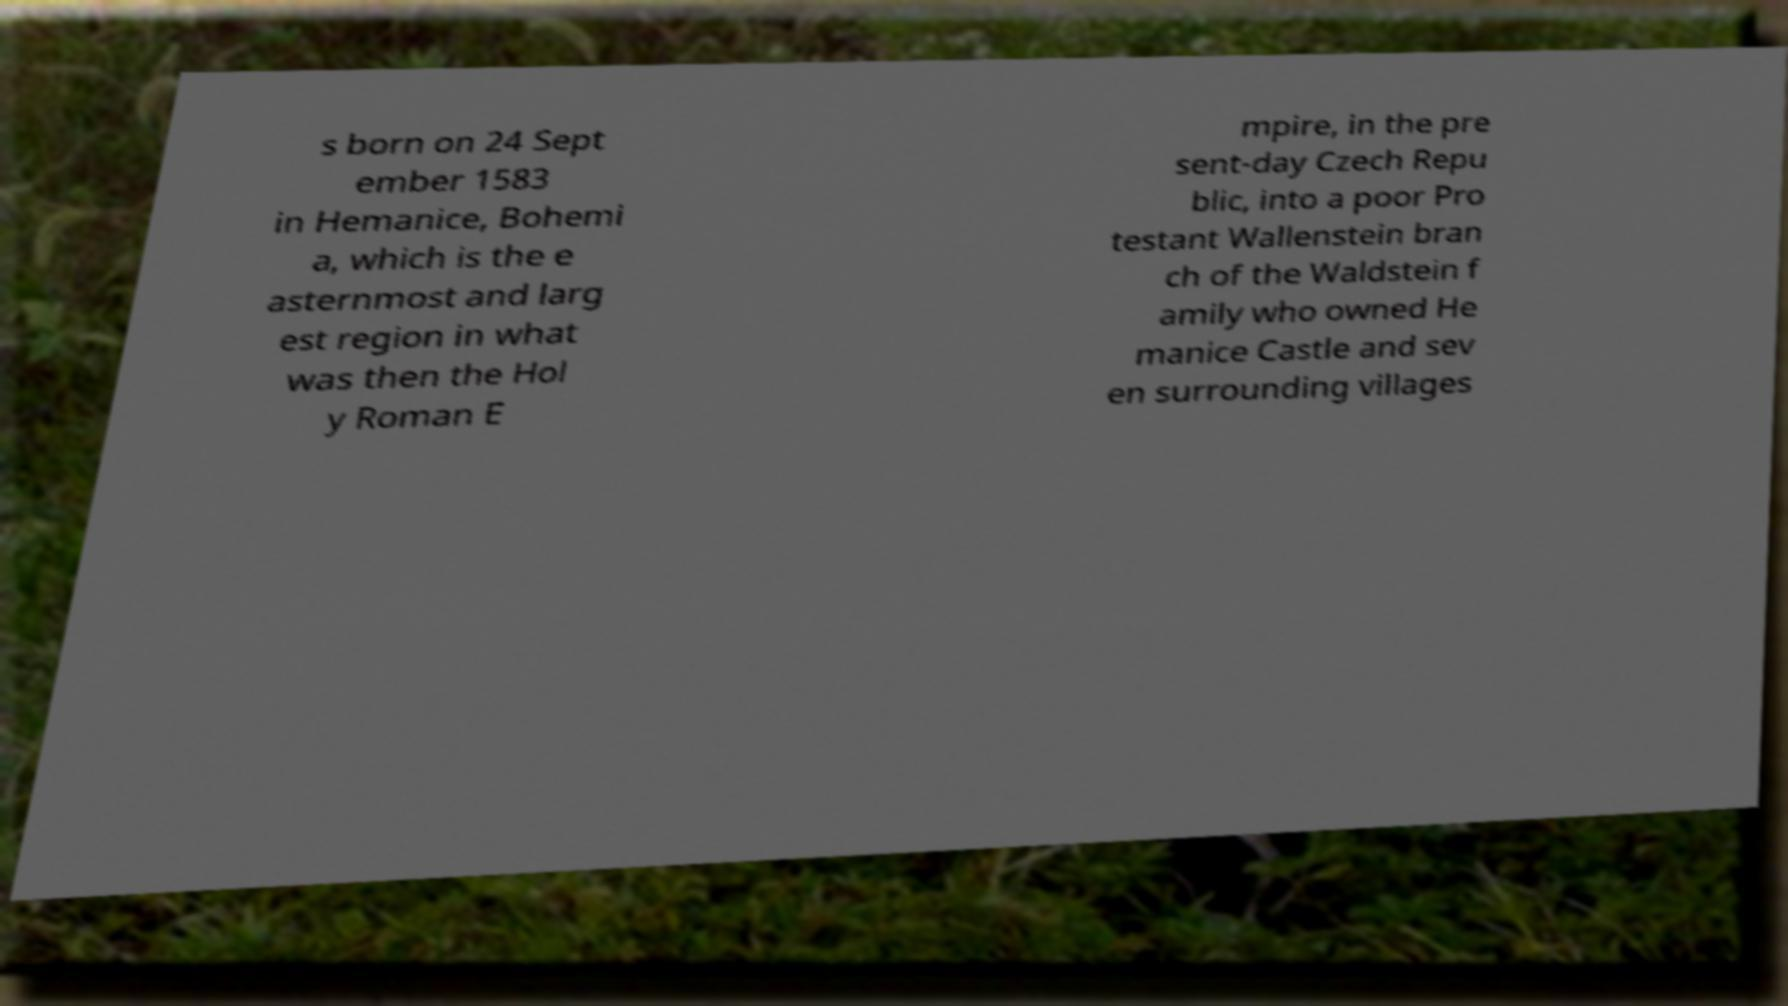I need the written content from this picture converted into text. Can you do that? s born on 24 Sept ember 1583 in Hemanice, Bohemi a, which is the e asternmost and larg est region in what was then the Hol y Roman E mpire, in the pre sent-day Czech Repu blic, into a poor Pro testant Wallenstein bran ch of the Waldstein f amily who owned He manice Castle and sev en surrounding villages 